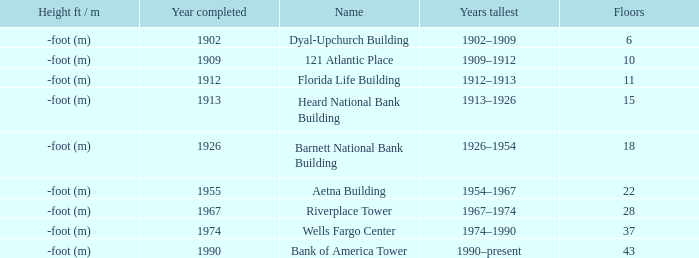How tall is the florida life building, completed before 1990? -foot (m). 